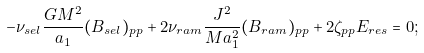Convert formula to latex. <formula><loc_0><loc_0><loc_500><loc_500>- \nu _ { s e l } \frac { G M ^ { 2 } } { a _ { 1 } } ( B _ { s e l } ) _ { p p } + 2 \nu _ { r a m } \frac { J ^ { 2 } } { M a _ { 1 } ^ { 2 } } ( B _ { r a m } ) _ { p p } + 2 \zeta _ { p p } E _ { r e s } = 0 ;</formula> 